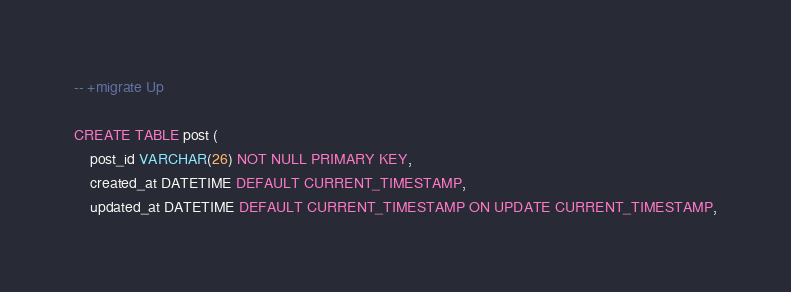Convert code to text. <code><loc_0><loc_0><loc_500><loc_500><_SQL_>-- +migrate Up

CREATE TABLE post (
    post_id VARCHAR(26) NOT NULL PRIMARY KEY,
    created_at DATETIME DEFAULT CURRENT_TIMESTAMP,
    updated_at DATETIME DEFAULT CURRENT_TIMESTAMP ON UPDATE CURRENT_TIMESTAMP,</code> 